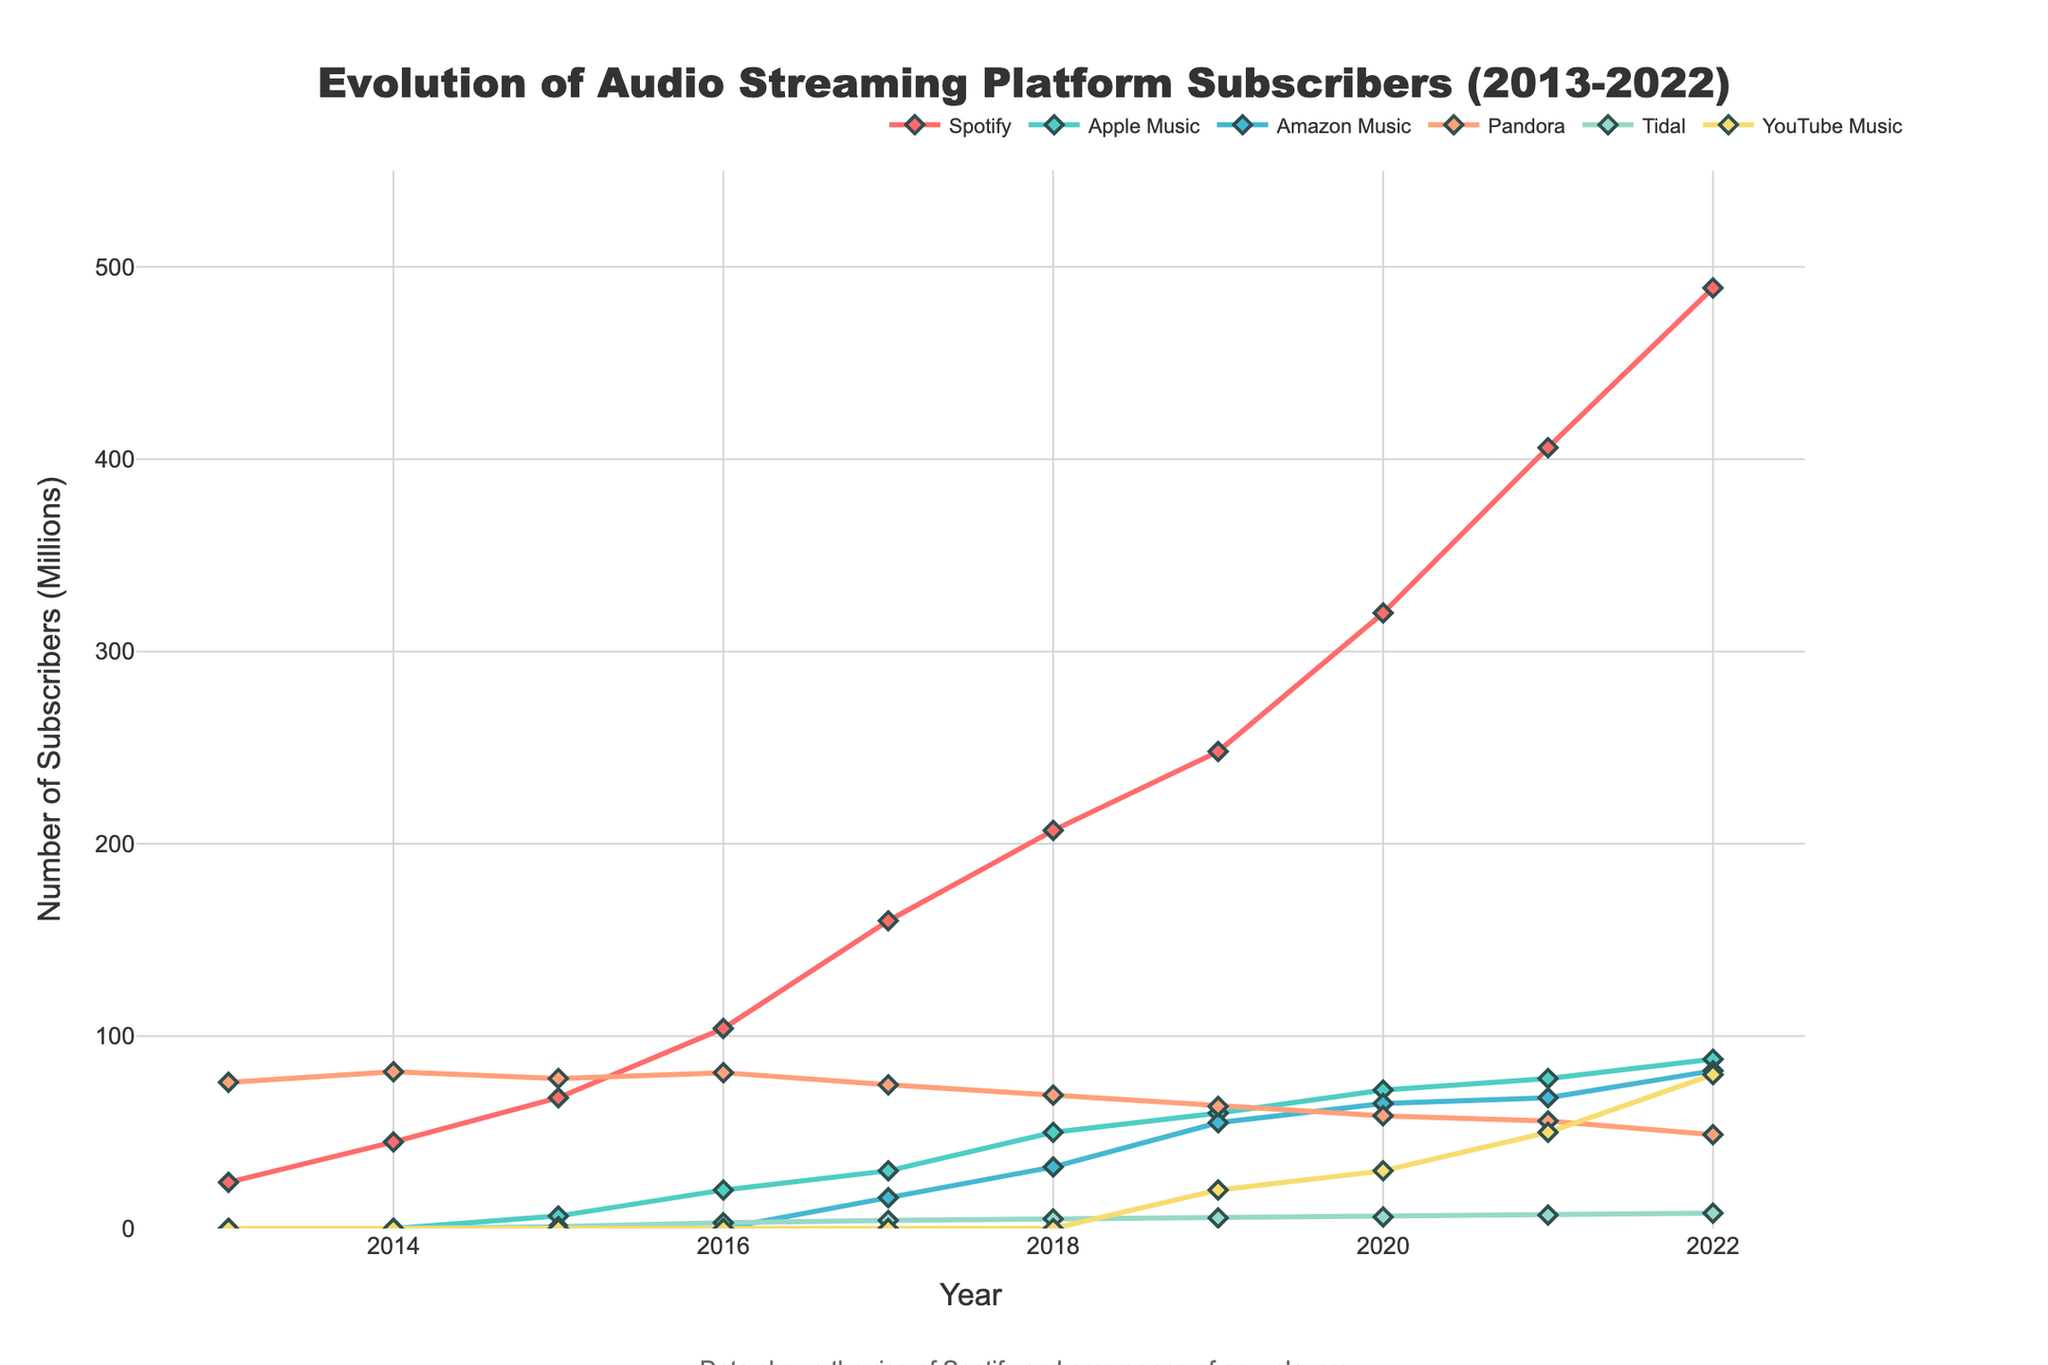What year did Spotify surpass 200 million subscribers? First, identify the line for Spotify on the chart. Then look for the point where the line first exceeds the 200 million mark. This occurs in 2018.
Answer: 2018 Compare the number of subscribers of Apple Music and Amazon Music in 2020. Which service had more subscribers? Locate the points for Apple Music and Amazon Music in 2020 directly from the figure. Apple Music had 72 million subscribers and Amazon Music had 65 million.
Answer: Apple Music How much did YouTube Music grow from 2019 to 2022 in million subscribers? Identify the points for YouTube Music in 2019 and 2022. In 2019, YouTube Music had 20 million subscribers, and in 2022 it had 80 million. Calculate the difference: 80 - 20 = 60.
Answer: 60 Which service had the highest number of subscribers in 2022? Look at the endpoints of all the lines in 2022. Spotify had the highest number of subscribers, at 489 million.
Answer: Spotify In 2015, what is the total number of subscribers for all the services combined? Identify the subscriber values for all services in 2015 and sum them: 68 (Spotify) + 6.5 (Apple Music) + 0 (Amazon Music) + 78 (Pandora) + 1 (Tidal) + 0 (YouTube Music) = 153.5.
Answer: 153.5 Which service showed the least growth between 2013 and 2022? Compare the initial and final points of all services. Pandora had 76 million subscribers in 2013 and 48.8 million in 2022, showing a decrease. All other services increased.
Answer: Pandora What is the color of the line representing Amazon Music? Referring to the color scheme in the plot, Amazon Music's line is represented in blue.
Answer: Blue Which year did Tidal first appear in the data, and how many subscribers did it have then? Find the first appearance of Tidal in the chart. It appears in 2015 with 1 million subscribers.
Answer: 2015, 1 million Between 2017 and 2019, which service experienced the greatest growth in subscribers? Calculate growth by subtracting the 2017 values from the 2019 values for all services. Spotify grew from 160 to 248 (88 million), Apple Music from 30 to 60 (30 million), Amazon Music from 16 to 55 (39 million), Pandora from 74.7 to 63.5 (decrease), Tidal from 4.2 to 5.5 (1.3 million), and YouTube Music from 0 to 20 (20 million). Spotify experienced the greatest growth.
Answer: Spotify Which two services had almost equal subscribers in 2021? Compare the values at 2021. Amazon Music and Pandora had similar numbers of subscribers: Amazon Music with 68 million and Pandora with 55.9 million—closest pair relative to the others.
Answer: Amazon Music and Pandora 